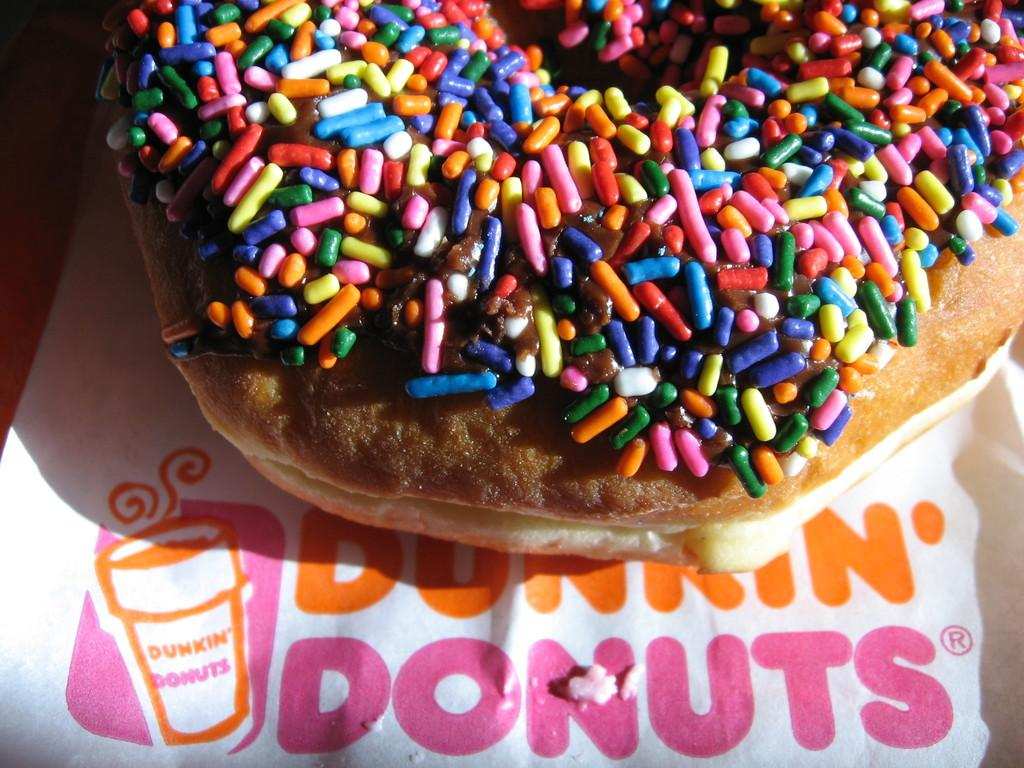What is the main subject of the image? The main subject of the image is a doughnut. Where is the doughnut located in the image? The doughnut is placed on a table. What is covering the table in the image? There is a white color table paper on the table. How many eggs are visible in the image? There are no eggs present in the image. What type of fowl can be seen in the image? There is no fowl present in the image. 